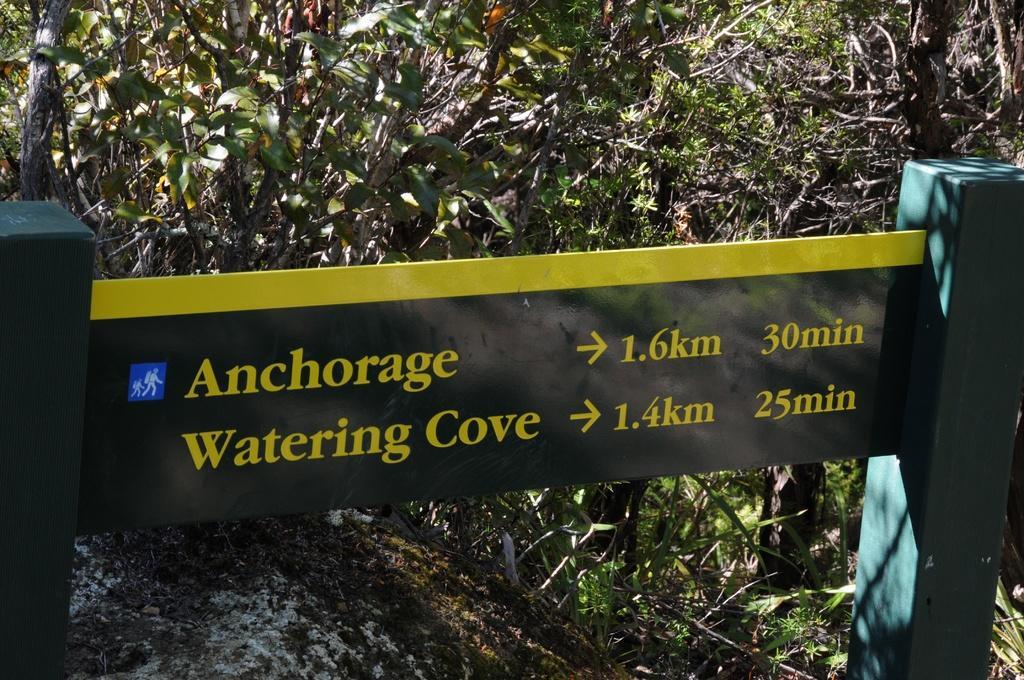Please provide a concise description of this image. In this picture we can see a direction sign board and in the background we can see trees. 